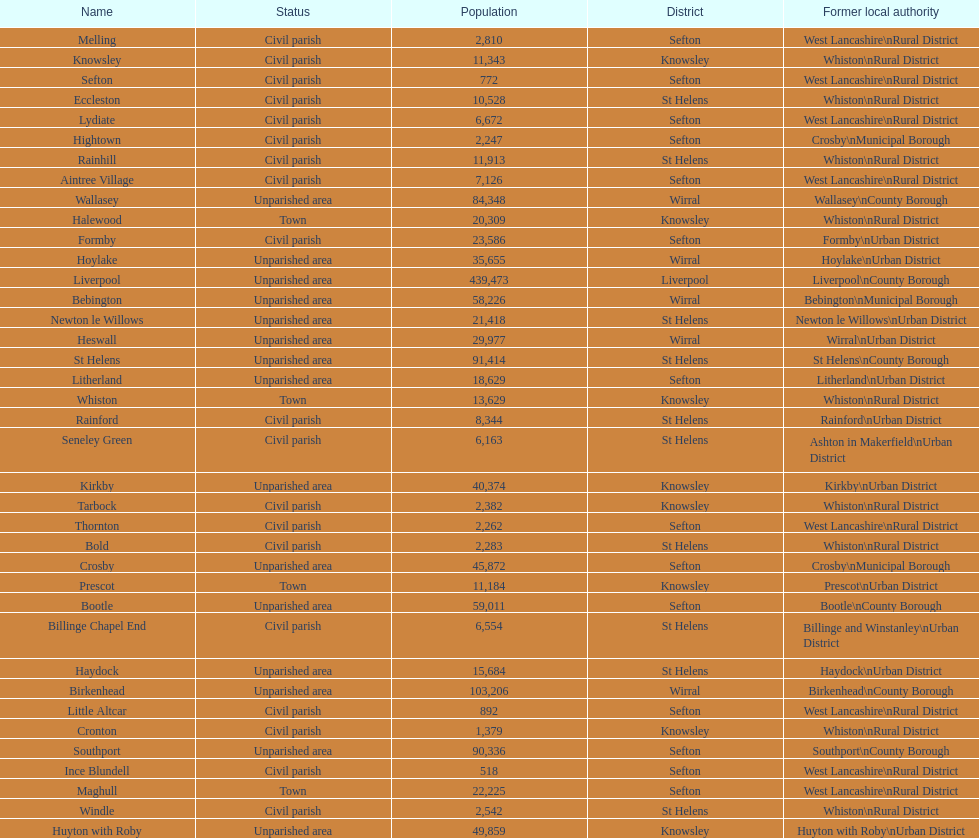Tell me the number of residents in formby. 23,586. 